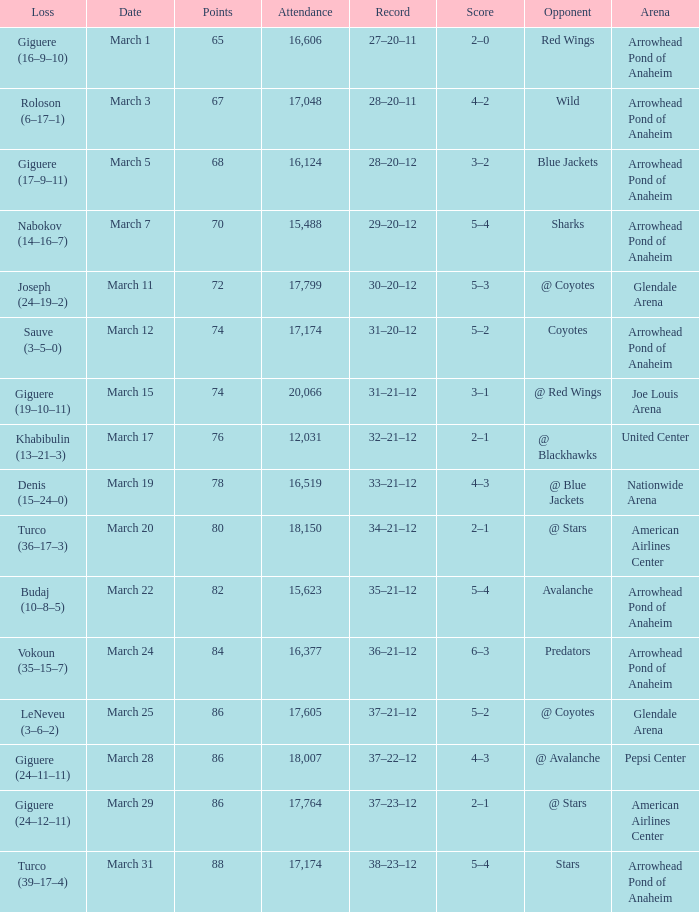What is the Attendance of the game with a Score of 3–2? 1.0. 